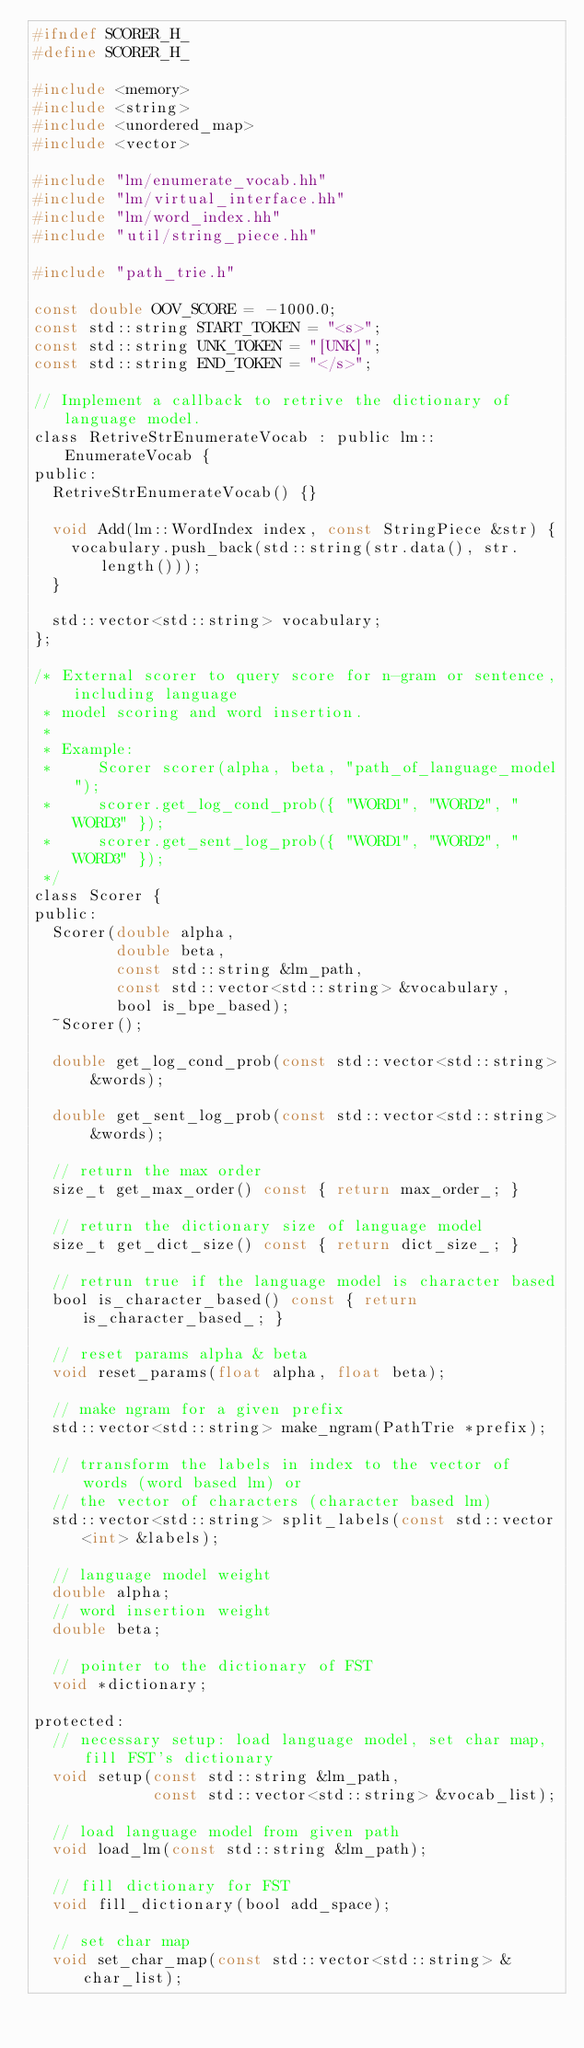Convert code to text. <code><loc_0><loc_0><loc_500><loc_500><_C_>#ifndef SCORER_H_
#define SCORER_H_

#include <memory>
#include <string>
#include <unordered_map>
#include <vector>

#include "lm/enumerate_vocab.hh"
#include "lm/virtual_interface.hh"
#include "lm/word_index.hh"
#include "util/string_piece.hh"

#include "path_trie.h"

const double OOV_SCORE = -1000.0;
const std::string START_TOKEN = "<s>";
const std::string UNK_TOKEN = "[UNK]";
const std::string END_TOKEN = "</s>";

// Implement a callback to retrive the dictionary of language model.
class RetriveStrEnumerateVocab : public lm::EnumerateVocab {
public:
  RetriveStrEnumerateVocab() {}

  void Add(lm::WordIndex index, const StringPiece &str) {
    vocabulary.push_back(std::string(str.data(), str.length()));
  }

  std::vector<std::string> vocabulary;
};

/* External scorer to query score for n-gram or sentence, including language
 * model scoring and word insertion.
 *
 * Example:
 *     Scorer scorer(alpha, beta, "path_of_language_model");
 *     scorer.get_log_cond_prob({ "WORD1", "WORD2", "WORD3" });
 *     scorer.get_sent_log_prob({ "WORD1", "WORD2", "WORD3" });
 */
class Scorer {
public:
  Scorer(double alpha,
         double beta,
         const std::string &lm_path,
         const std::vector<std::string> &vocabulary,
         bool is_bpe_based);
  ~Scorer();

  double get_log_cond_prob(const std::vector<std::string> &words);

  double get_sent_log_prob(const std::vector<std::string> &words);

  // return the max order
  size_t get_max_order() const { return max_order_; }

  // return the dictionary size of language model
  size_t get_dict_size() const { return dict_size_; }

  // retrun true if the language model is character based
  bool is_character_based() const { return is_character_based_; }

  // reset params alpha & beta
  void reset_params(float alpha, float beta);

  // make ngram for a given prefix
  std::vector<std::string> make_ngram(PathTrie *prefix);

  // trransform the labels in index to the vector of words (word based lm) or
  // the vector of characters (character based lm)
  std::vector<std::string> split_labels(const std::vector<int> &labels);

  // language model weight
  double alpha;
  // word insertion weight
  double beta;

  // pointer to the dictionary of FST
  void *dictionary;

protected:
  // necessary setup: load language model, set char map, fill FST's dictionary
  void setup(const std::string &lm_path,
             const std::vector<std::string> &vocab_list);

  // load language model from given path
  void load_lm(const std::string &lm_path);

  // fill dictionary for FST
  void fill_dictionary(bool add_space);

  // set char map
  void set_char_map(const std::vector<std::string> &char_list);
</code> 